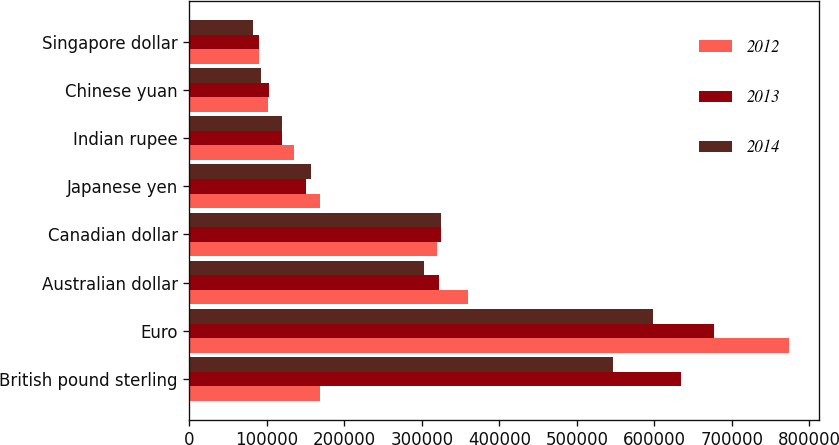Convert chart to OTSL. <chart><loc_0><loc_0><loc_500><loc_500><stacked_bar_chart><ecel><fcel>British pound sterling<fcel>Euro<fcel>Australian dollar<fcel>Canadian dollar<fcel>Japanese yen<fcel>Indian rupee<fcel>Chinese yuan<fcel>Singapore dollar<nl><fcel>2012<fcel>168574<fcel>773753<fcel>359660<fcel>319670<fcel>168574<fcel>135139<fcel>101790<fcel>89343<nl><fcel>2013<fcel>634375<fcel>677258<fcel>322792<fcel>324900<fcel>151050<fcel>118944<fcel>102643<fcel>89509<nl><fcel>2014<fcel>547339<fcel>598621<fcel>302463<fcel>324304<fcel>157007<fcel>119327<fcel>92215<fcel>82069<nl></chart> 